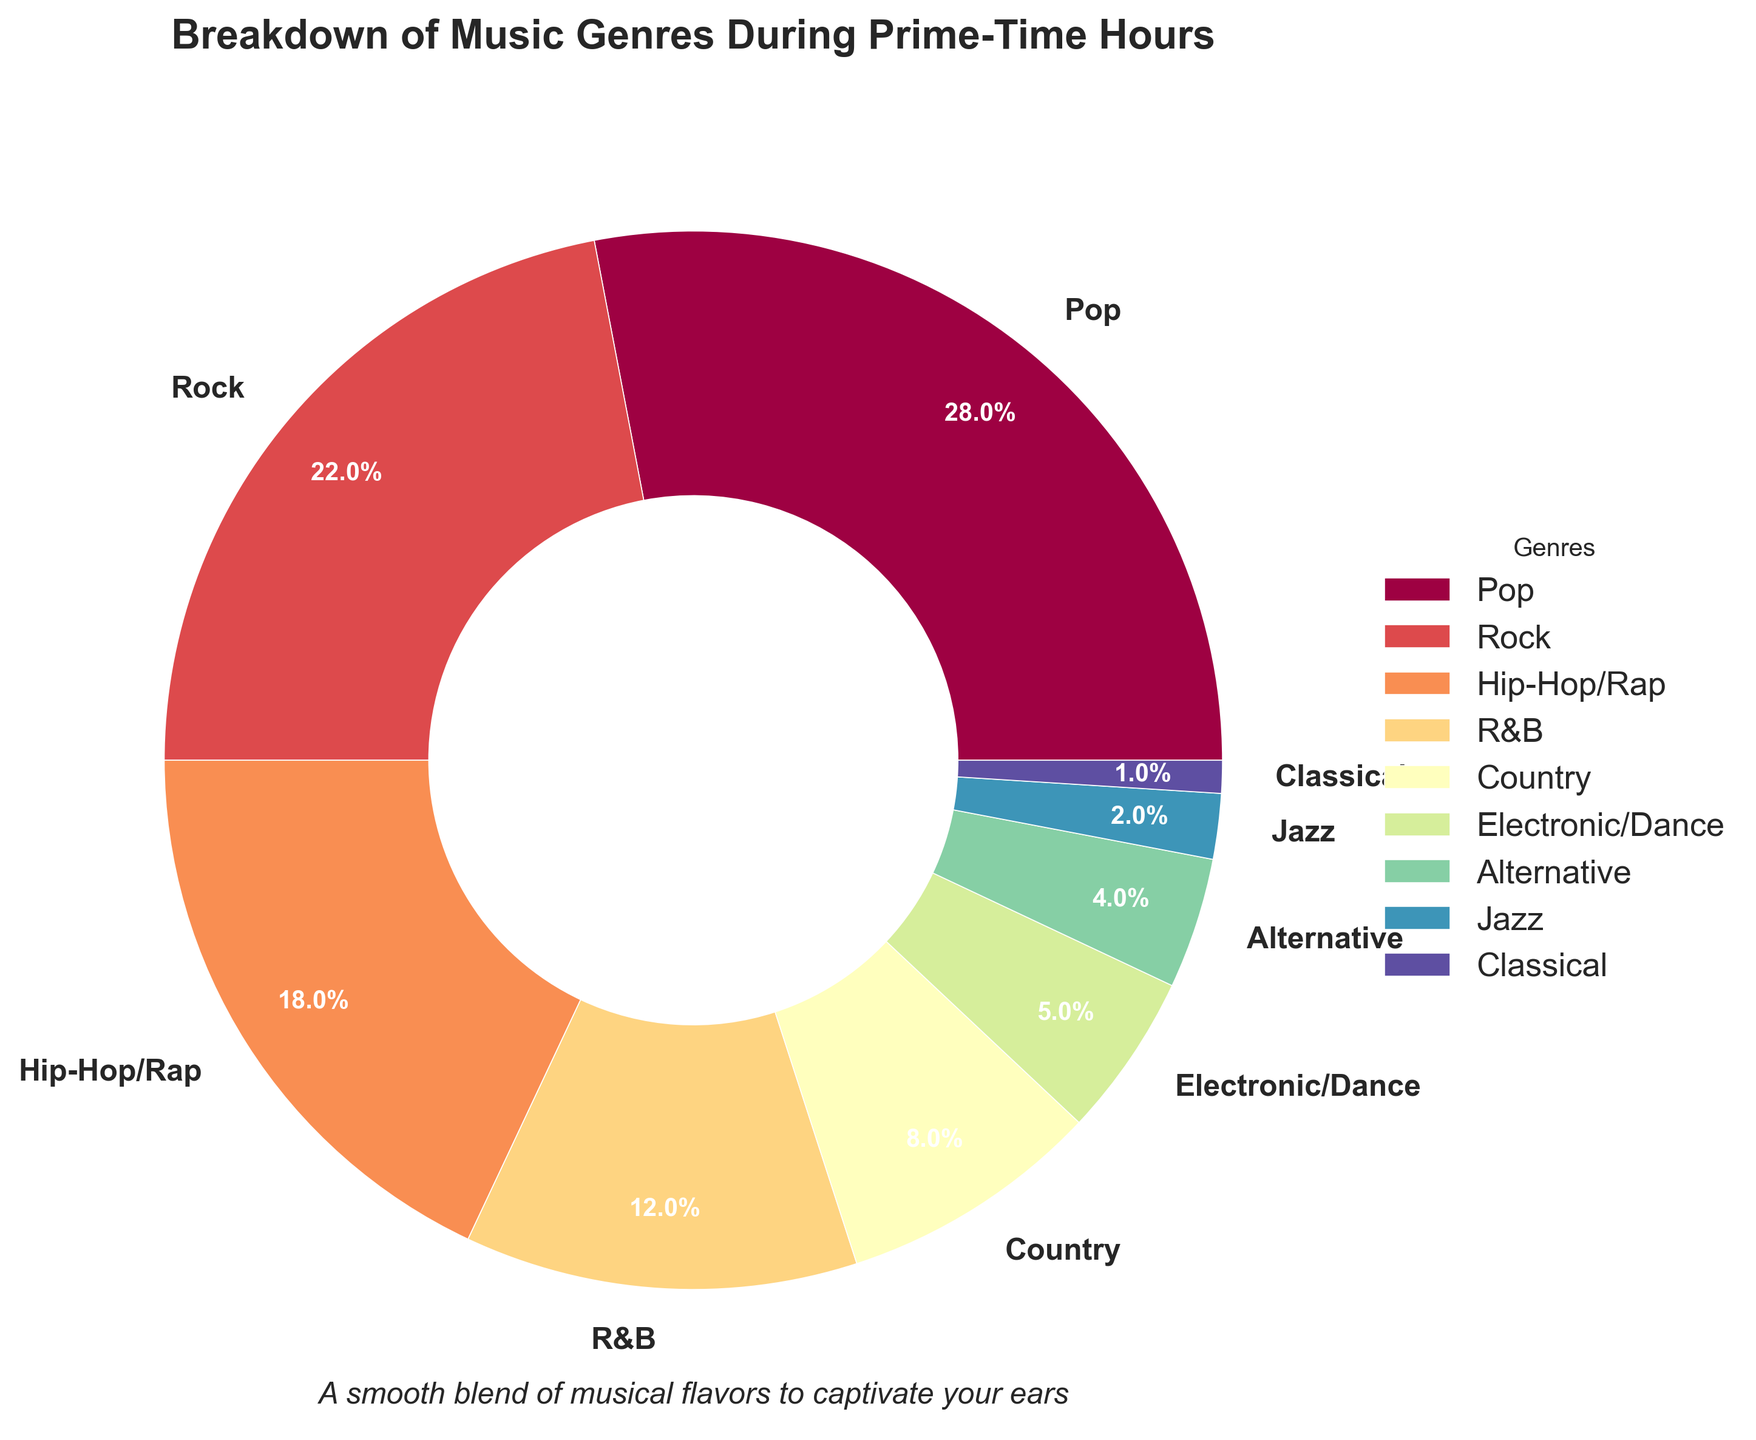Which genre has the highest percentage of airplay during prime-time hours? Pop has the highest percentage at 28%, as clearly shown by the largest section of the pie chart.
Answer: Pop What percentage of airplay do Pop and Rock together account for? Adding the percentages for Pop (28%) and Rock (22%), we get 28 + 22 = 50%.
Answer: 50% How much more airplay percentage does Pop have compared to Electronic/Dance? Pop has 28% while Electronic/Dance has 5%. The difference is calculated as 28 - 5 = 23%.
Answer: 23% Which genres are represented by the smallest slices in the pie chart? Jazz, Classical, and Alternative are the smallest visible slices with 2%, 1%, and 4% respectively.
Answer: Jazz, Classical, Alternative Does the combined percentage of Hip-Hop/Rap and R&B exceed the percentage of Pop? Hip-Hop/Rap is 18% and R&B is 12%, so combined they are 18 + 12 = 30%. This is more than Pop's 28%.
Answer: Yes How many genres have a percentage that is less than 10% but still greater than or equal to 5%? Country (8%), Electronic/Dance (5%), and Alternative (4%) – only Country and Electronic/Dance fit this criterion.
Answer: 2 What is the total percentage of airplay for genres with less than or equal to 2%? Jazz (2%) and Classical (1%) are the only ones visible in the pie chart under this criteria. Adding them together gives us 2 + 1 = 3%.
Answer: 3% Which has a higher percentage, R&B or Country, and by how much? R&B is 12% and Country is 8%, so R&B is higher by 12 - 8 = 4%.
Answer: R&B, 4% If a listener tunes in during prime-time, what is the probability in percentage that they will hear either Rock or Hip-Hop/Rap? Rock is 22% and Hip-Hop/Rap is 18%. The combined percentage is 22 + 18 = 40%.
Answer: 40% 